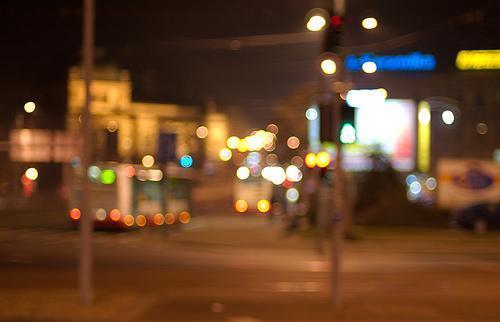How many bus are there?
Give a very brief answer. 2. 